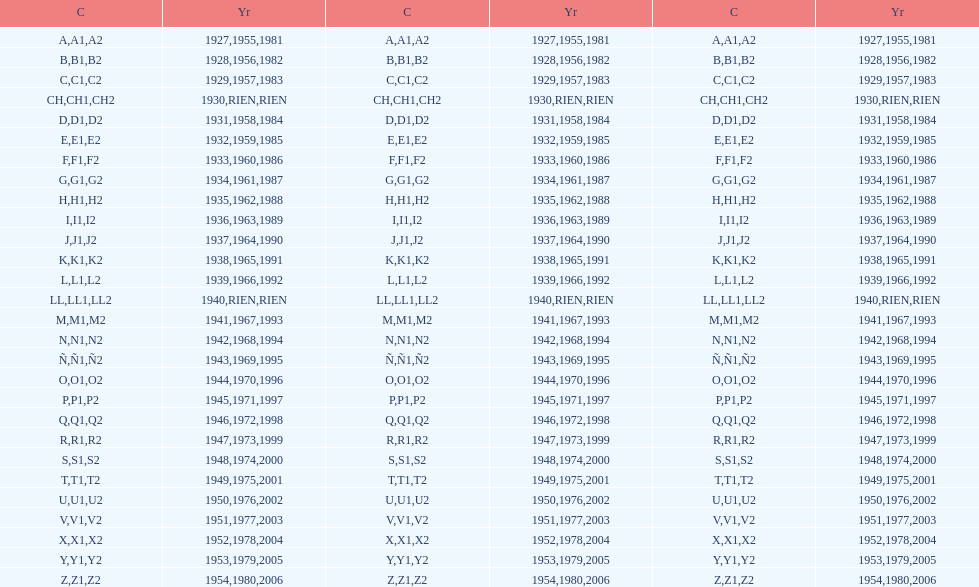Parse the full table. {'header': ['C', 'Yr', 'C', 'Yr', 'C', 'Yr'], 'rows': [['A', '1927', 'A1', '1955', 'A2', '1981'], ['B', '1928', 'B1', '1956', 'B2', '1982'], ['C', '1929', 'C1', '1957', 'C2', '1983'], ['CH', '1930', 'CH1', 'RIEN', 'CH2', 'RIEN'], ['D', '1931', 'D1', '1958', 'D2', '1984'], ['E', '1932', 'E1', '1959', 'E2', '1985'], ['F', '1933', 'F1', '1960', 'F2', '1986'], ['G', '1934', 'G1', '1961', 'G2', '1987'], ['H', '1935', 'H1', '1962', 'H2', '1988'], ['I', '1936', 'I1', '1963', 'I2', '1989'], ['J', '1937', 'J1', '1964', 'J2', '1990'], ['K', '1938', 'K1', '1965', 'K2', '1991'], ['L', '1939', 'L1', '1966', 'L2', '1992'], ['LL', '1940', 'LL1', 'RIEN', 'LL2', 'RIEN'], ['M', '1941', 'M1', '1967', 'M2', '1993'], ['N', '1942', 'N1', '1968', 'N2', '1994'], ['Ñ', '1943', 'Ñ1', '1969', 'Ñ2', '1995'], ['O', '1944', 'O1', '1970', 'O2', '1996'], ['P', '1945', 'P1', '1971', 'P2', '1997'], ['Q', '1946', 'Q1', '1972', 'Q2', '1998'], ['R', '1947', 'R1', '1973', 'R2', '1999'], ['S', '1948', 'S1', '1974', 'S2', '2000'], ['T', '1949', 'T1', '1975', 'T2', '2001'], ['U', '1950', 'U1', '1976', 'U2', '2002'], ['V', '1951', 'V1', '1977', 'V2', '2003'], ['X', '1952', 'X1', '1978', 'X2', '2004'], ['Y', '1953', 'Y1', '1979', 'Y2', '2005'], ['Z', '1954', 'Z1', '1980', 'Z2', '2006']]} How many diverse codes were applied during 1953 to 1958? 6. 